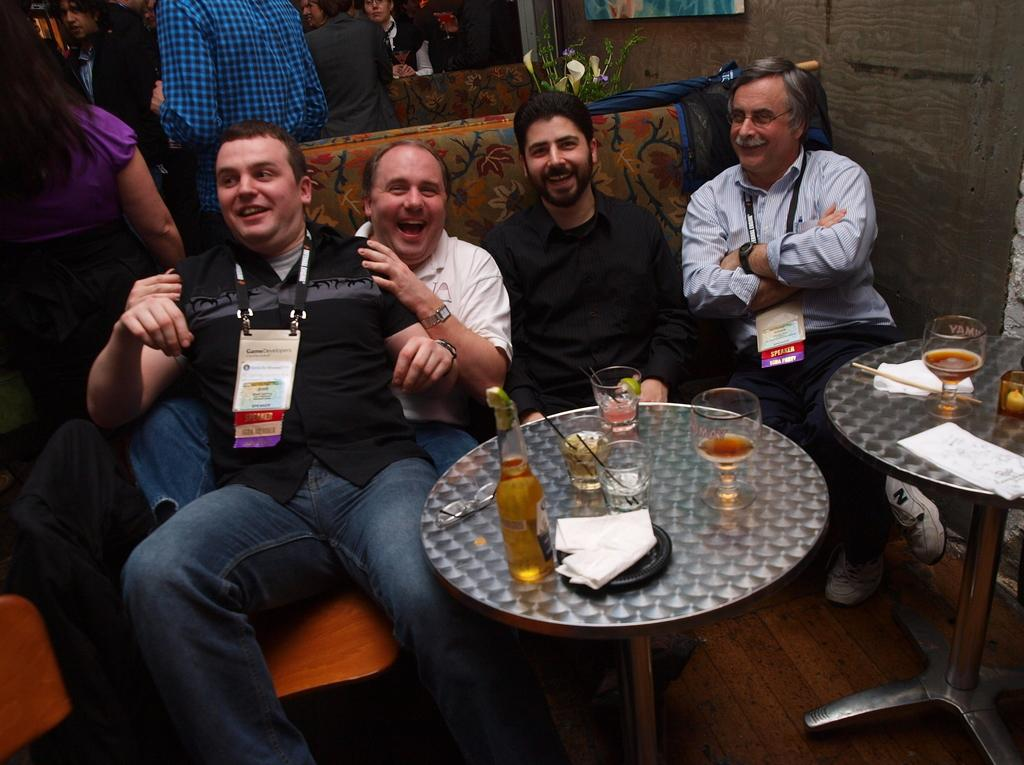What are the men in the image doing? The men in the image are sitting on a sofa. What is in front of the sofa? There is a table in front of the sofa. What can be seen on the table? There is a wine bottle and glasses on the table. What type of establishment might the setting be in? The setting appears to be in a bar. What channel is the guide showing on the TV in the image? There is no TV or guide present in the image. 